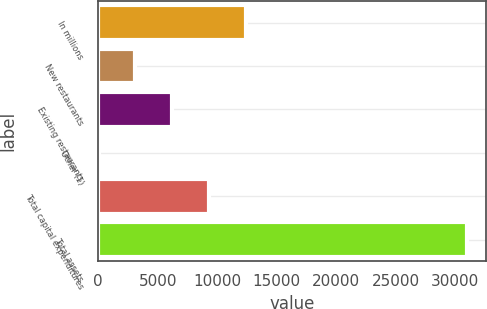<chart> <loc_0><loc_0><loc_500><loc_500><bar_chart><fcel>In millions<fcel>New restaurants<fcel>Existing restaurants<fcel>Other (1)<fcel>Total capital expenditures<fcel>Total assets<nl><fcel>12433<fcel>3137.5<fcel>6236<fcel>39<fcel>9334.5<fcel>31024<nl></chart> 